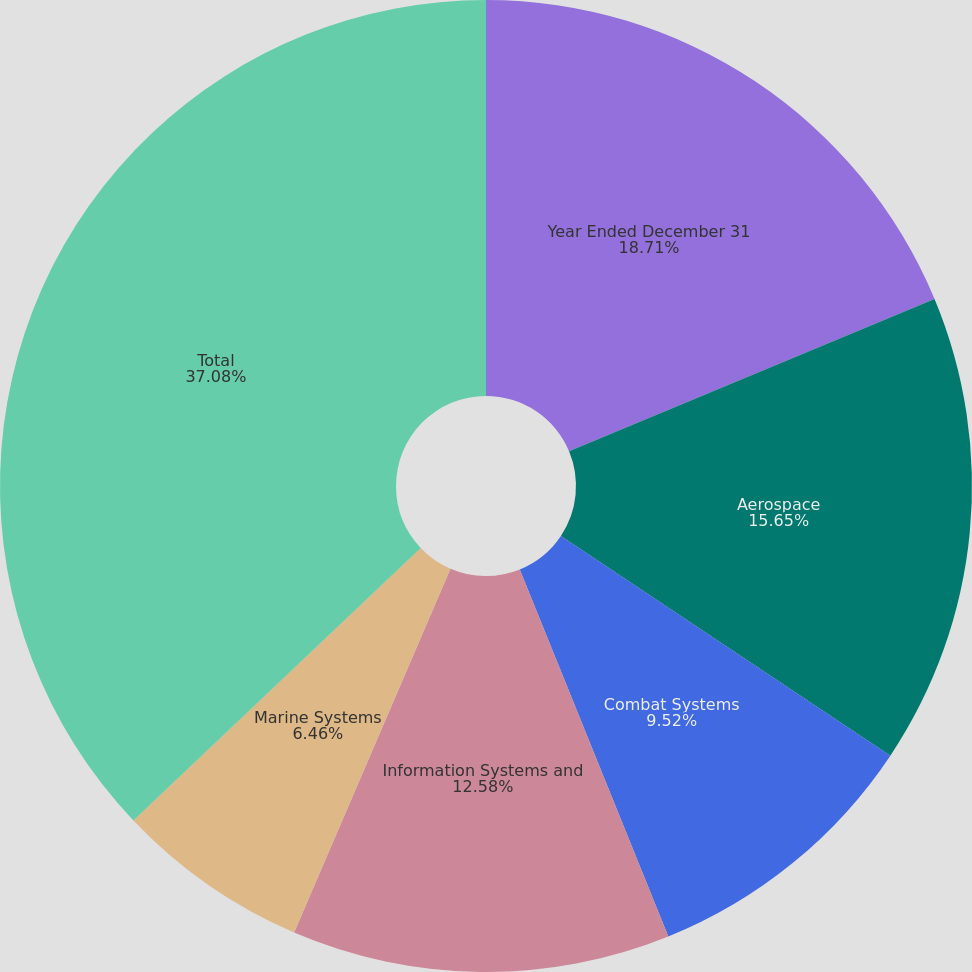Convert chart to OTSL. <chart><loc_0><loc_0><loc_500><loc_500><pie_chart><fcel>Year Ended December 31<fcel>Aerospace<fcel>Combat Systems<fcel>Information Systems and<fcel>Marine Systems<fcel>Total<nl><fcel>18.71%<fcel>15.65%<fcel>9.52%<fcel>12.58%<fcel>6.46%<fcel>37.08%<nl></chart> 